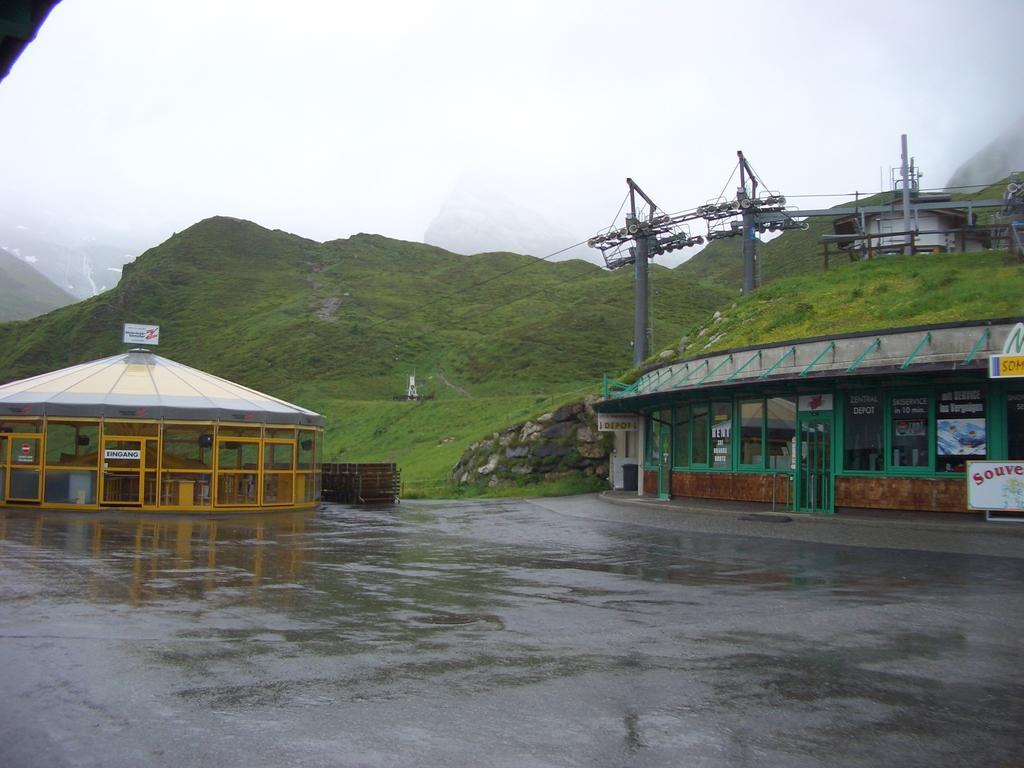How would you summarize this image in a sentence or two? In this picture we can see few houses, trees, land and hills. 